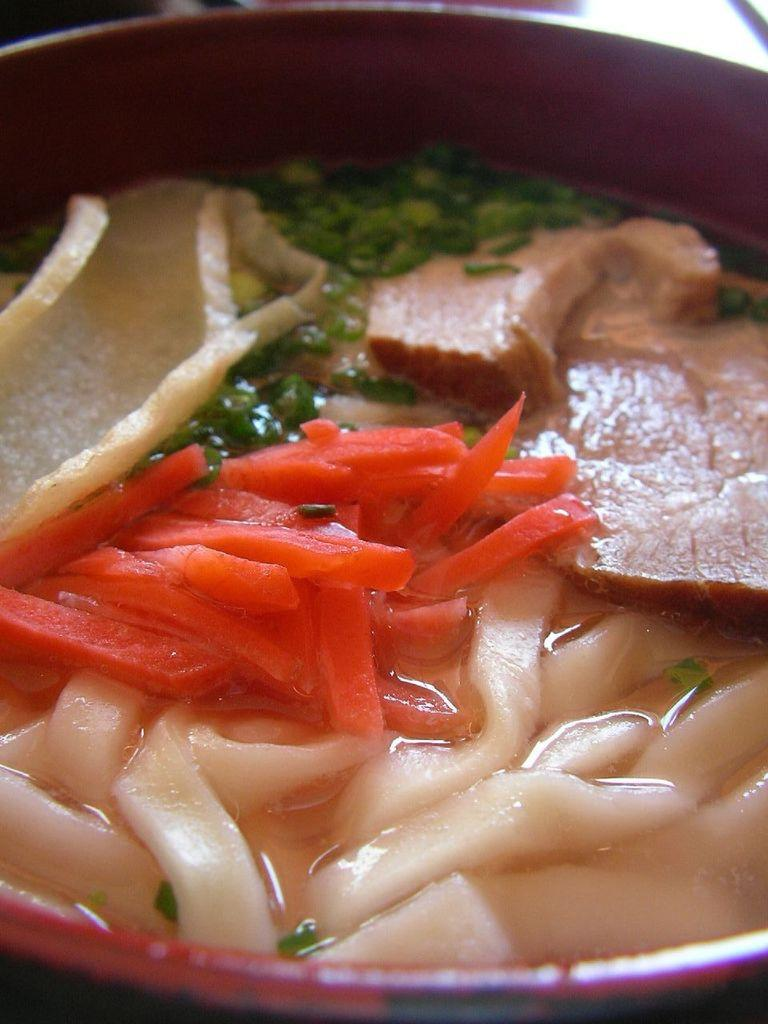What is in the bowl that is visible in the image? There is a bowl with food in the image. What color is the bowl? The bowl is maroon-colored. What type of food can be seen in the bowl? There are carrot pieces in the bowl. What type of boot is visible in the image? There is no boot present in the image. What flavor of mint can be seen in the image? There is no mint present in the image. 